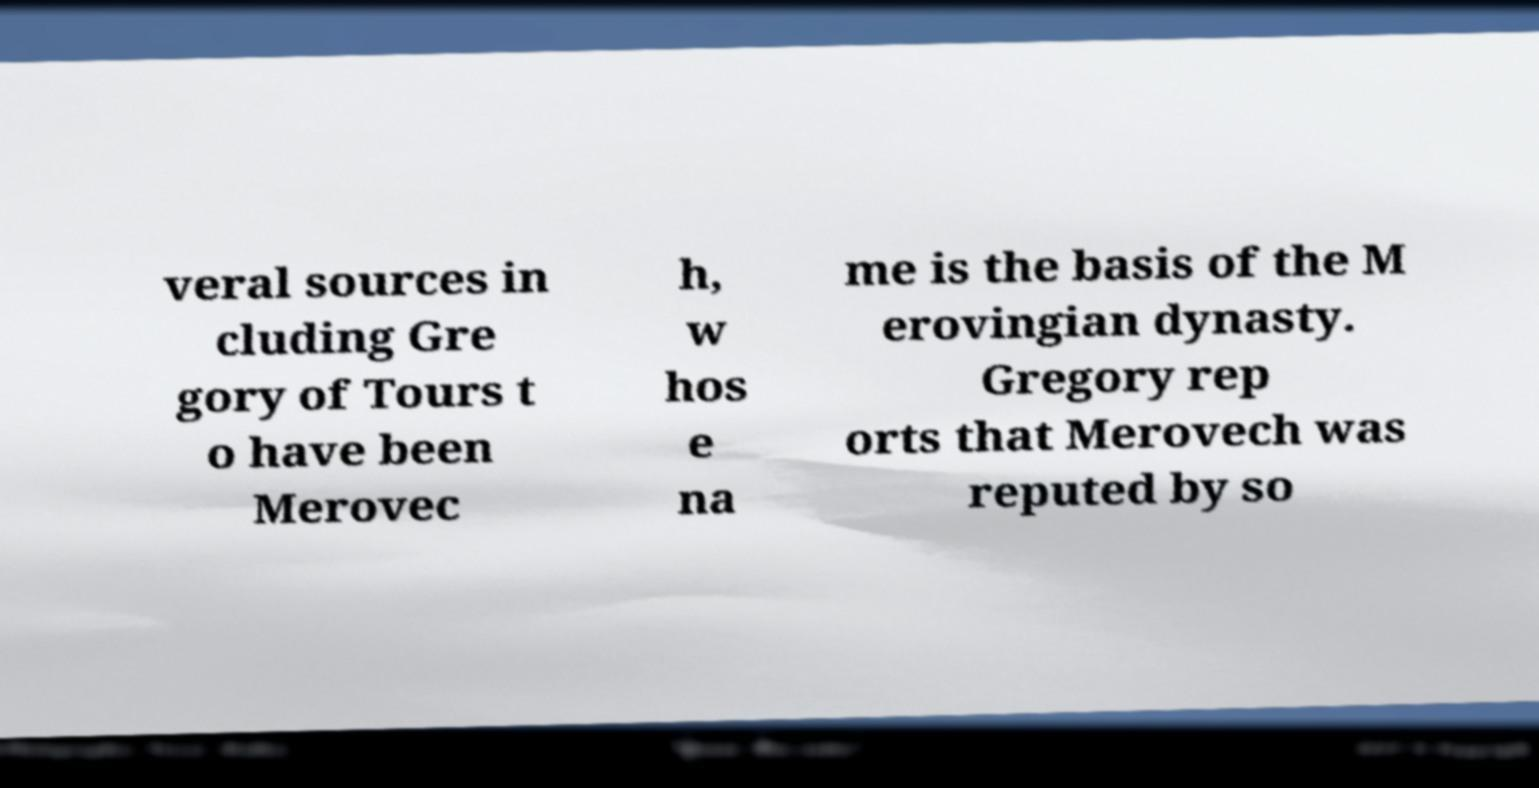Please identify and transcribe the text found in this image. veral sources in cluding Gre gory of Tours t o have been Merovec h, w hos e na me is the basis of the M erovingian dynasty. Gregory rep orts that Merovech was reputed by so 